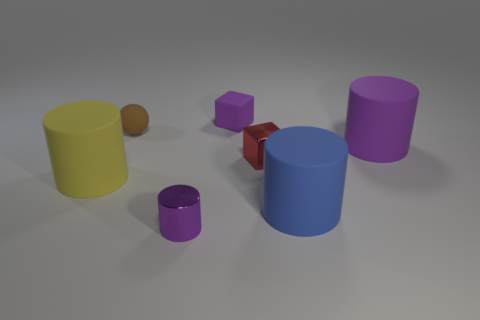Subtract 1 cylinders. How many cylinders are left? 3 Subtract all blue cylinders. How many cylinders are left? 3 Subtract all big yellow rubber cylinders. How many cylinders are left? 3 Subtract all cyan cylinders. Subtract all purple cubes. How many cylinders are left? 4 Add 2 blue metal cubes. How many objects exist? 9 Subtract all blocks. How many objects are left? 5 Add 2 cylinders. How many cylinders exist? 6 Subtract 1 yellow cylinders. How many objects are left? 6 Subtract all small metal blocks. Subtract all small brown balls. How many objects are left? 5 Add 5 large things. How many large things are left? 8 